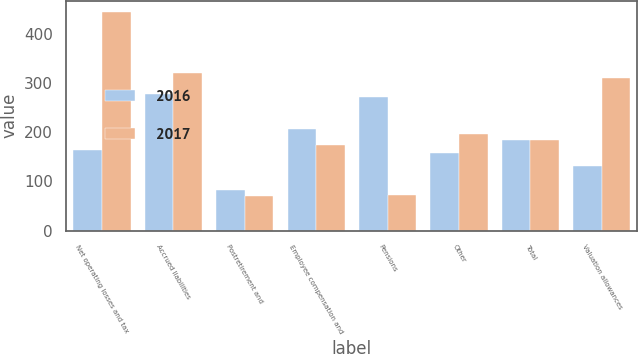Convert chart to OTSL. <chart><loc_0><loc_0><loc_500><loc_500><stacked_bar_chart><ecel><fcel>Net operating losses and tax<fcel>Accrued liabilities<fcel>Postretirement and<fcel>Employee compensation and<fcel>Pensions<fcel>Other<fcel>Total<fcel>Valuation allowances<nl><fcel>2016<fcel>164<fcel>277<fcel>82<fcel>206<fcel>271<fcel>158<fcel>184.5<fcel>132<nl><fcel>2017<fcel>444<fcel>319<fcel>70<fcel>173<fcel>72<fcel>196<fcel>184.5<fcel>309<nl></chart> 